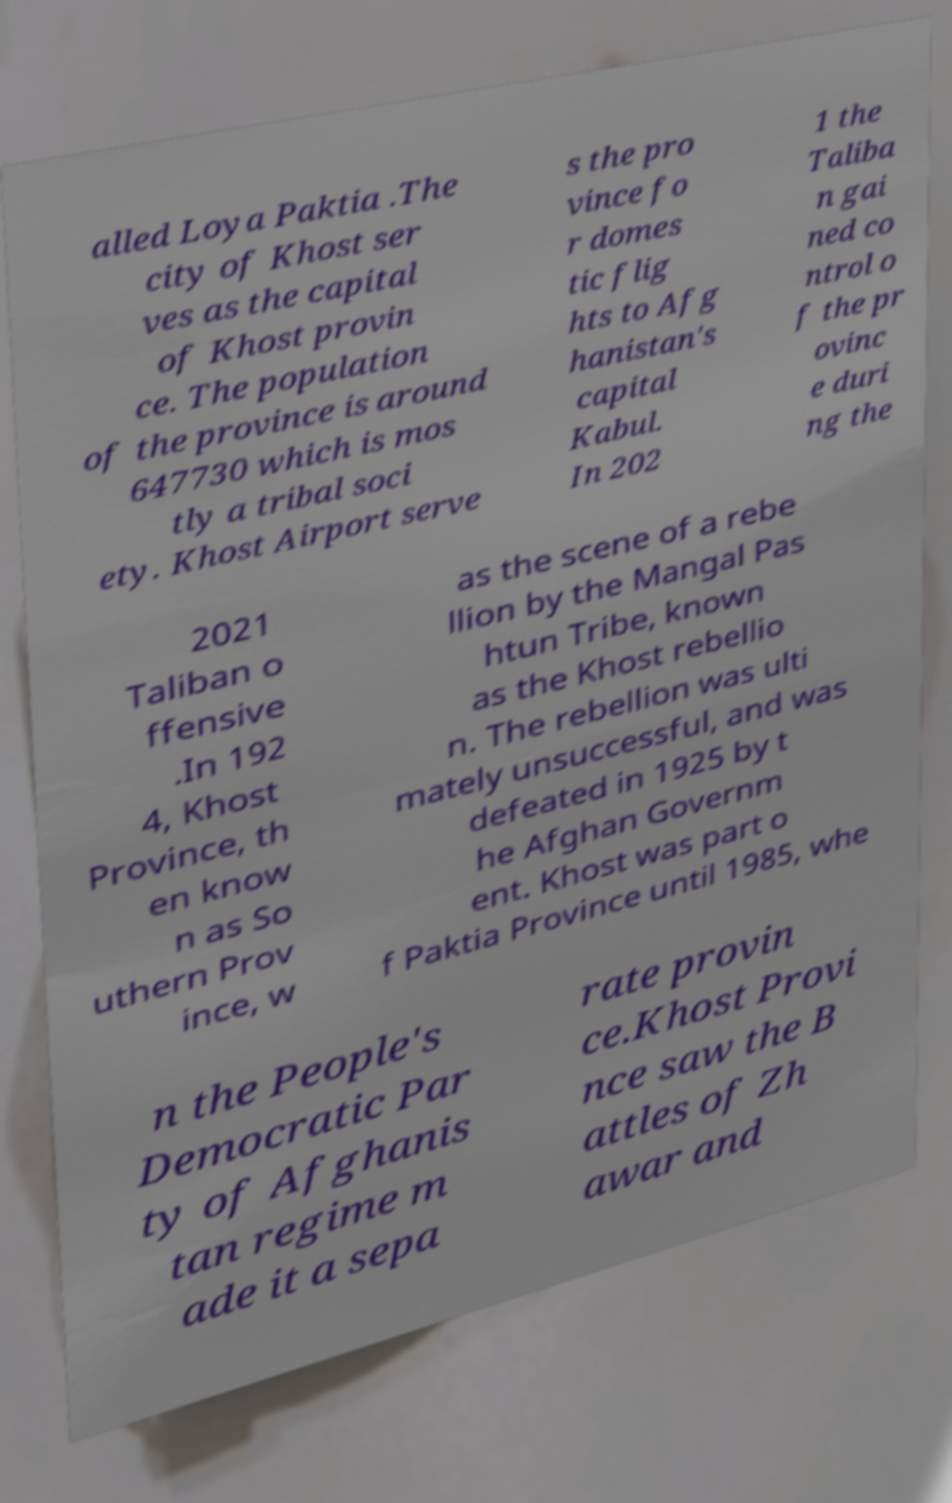Could you assist in decoding the text presented in this image and type it out clearly? alled Loya Paktia .The city of Khost ser ves as the capital of Khost provin ce. The population of the province is around 647730 which is mos tly a tribal soci ety. Khost Airport serve s the pro vince fo r domes tic flig hts to Afg hanistan's capital Kabul. In 202 1 the Taliba n gai ned co ntrol o f the pr ovinc e duri ng the 2021 Taliban o ffensive .In 192 4, Khost Province, th en know n as So uthern Prov ince, w as the scene of a rebe llion by the Mangal Pas htun Tribe, known as the Khost rebellio n. The rebellion was ulti mately unsuccessful, and was defeated in 1925 by t he Afghan Governm ent. Khost was part o f Paktia Province until 1985, whe n the People's Democratic Par ty of Afghanis tan regime m ade it a sepa rate provin ce.Khost Provi nce saw the B attles of Zh awar and 